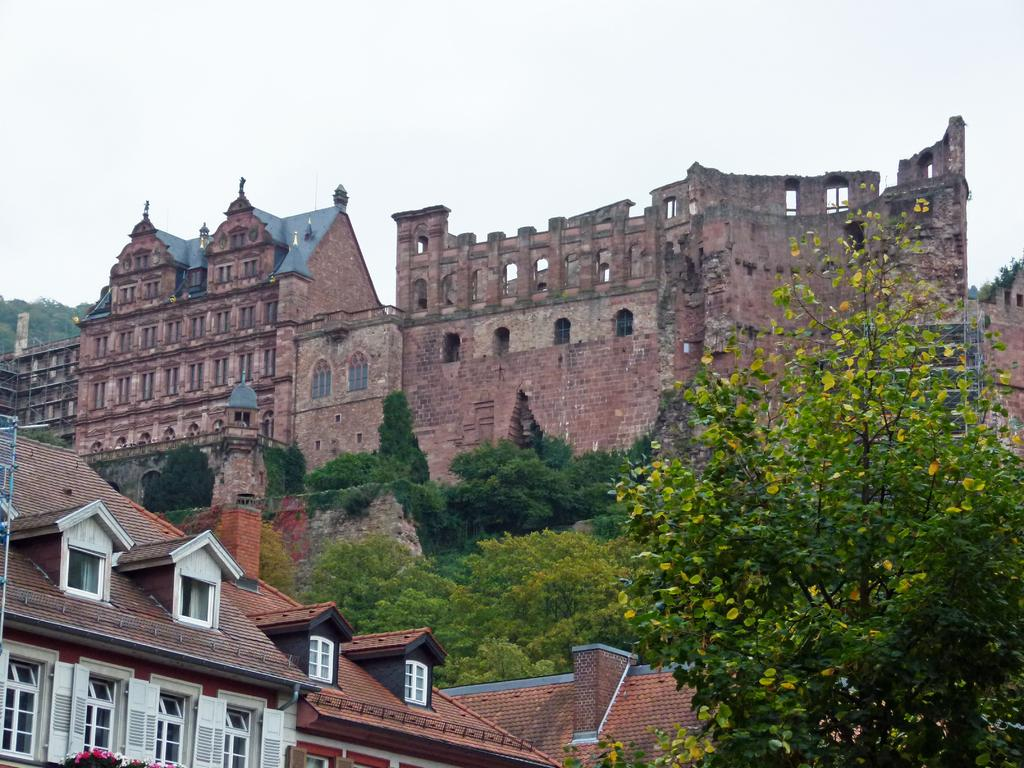What type of structures are present in the image? There are buildings in the image. What feature can be seen on the buildings? The buildings have windows. What type of vegetation is present in the image? There are trees in the image. What is visible in the background of the image? The sky is visible in the image. What type of bone is visible in the image? There is no bone present in the image. What kind of apparatus can be seen in the image? There is no apparatus present in the image. 